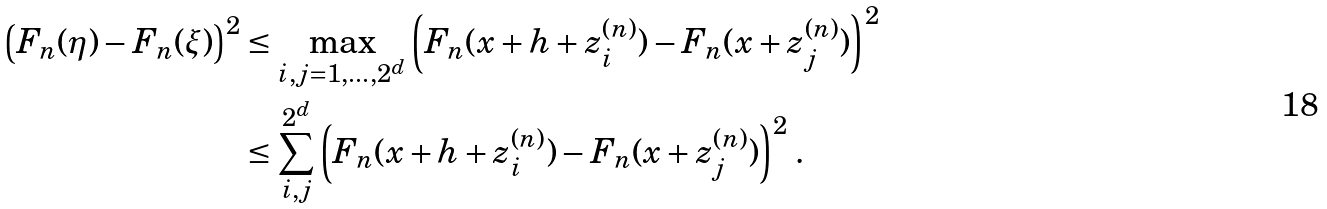<formula> <loc_0><loc_0><loc_500><loc_500>\left ( F _ { n } ( \eta ) - F _ { n } ( \xi ) \right ) ^ { 2 } & \leq \max _ { i , j = 1 , \dots , 2 ^ { d } } \left ( F _ { n } ( x + h + z ^ { ( n ) } _ { i } ) - F _ { n } ( x + z ^ { ( n ) } _ { j } ) \right ) ^ { 2 } \\ & \leq \sum _ { i , j } ^ { 2 ^ { d } } \left ( F _ { n } ( x + h + z ^ { ( n ) } _ { i } ) - F _ { n } ( x + z ^ { ( n ) } _ { j } ) \right ) ^ { 2 } \, .</formula> 